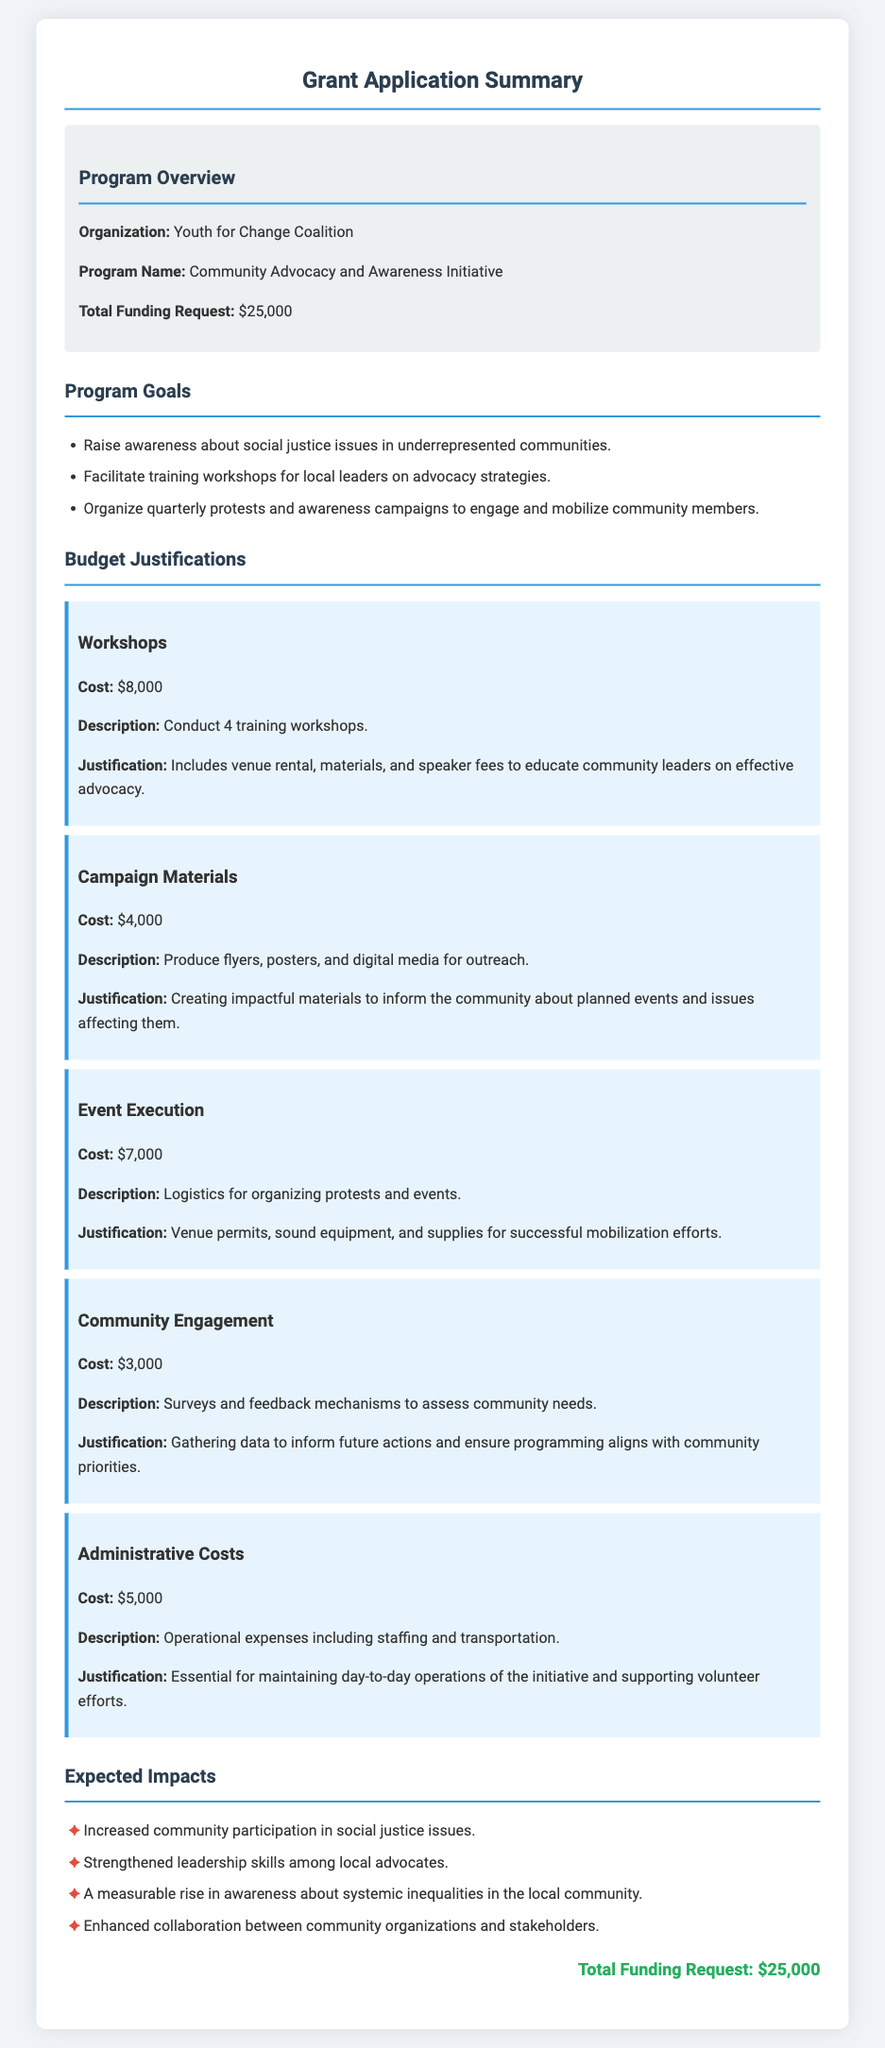What is the organization name? The organization is identified in the document as the Youth for Change Coalition.
Answer: Youth for Change Coalition What is the total funding request? The total funding request is stated clearly in the document.
Answer: $25,000 How many workshops are planned? The number of workshops is specified in the budget justification for the workshops section.
Answer: 4 What is the cost for community engagement? The cost specifically allocated for community engagement is detailed in the budget item.
Answer: $3,000 What is one goal of the program? The document lists multiple goals, one of which can be extracted directly.
Answer: Raise awareness about social justice issues in underrepresented communities What is the cost for campaign materials? The cost for campaign materials is explicitly mentioned in the budget section of the document.
Answer: $4,000 What is included in administrative costs? The description under administrative costs outlines what these costs involve.
Answer: Operational expenses including staffing and transportation How is the funding going to impact the community? The expected impacts section lists various anticipated outcomes from the funding request.
Answer: Increased community participation in social justice issues What is the description for event execution costs? The description can be found in the budget justification for the event execution item.
Answer: Logistics for organizing protests and events 